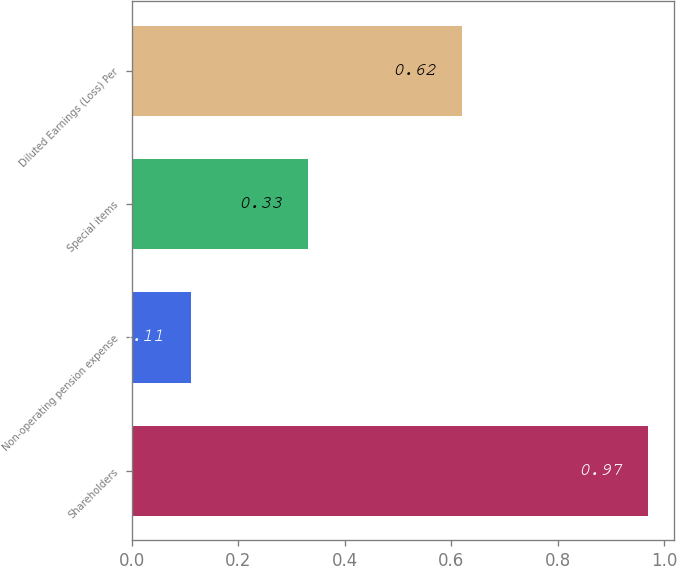<chart> <loc_0><loc_0><loc_500><loc_500><bar_chart><fcel>Shareholders<fcel>Non-operating pension expense<fcel>Special items<fcel>Diluted Earnings (Loss) Per<nl><fcel>0.97<fcel>0.11<fcel>0.33<fcel>0.62<nl></chart> 